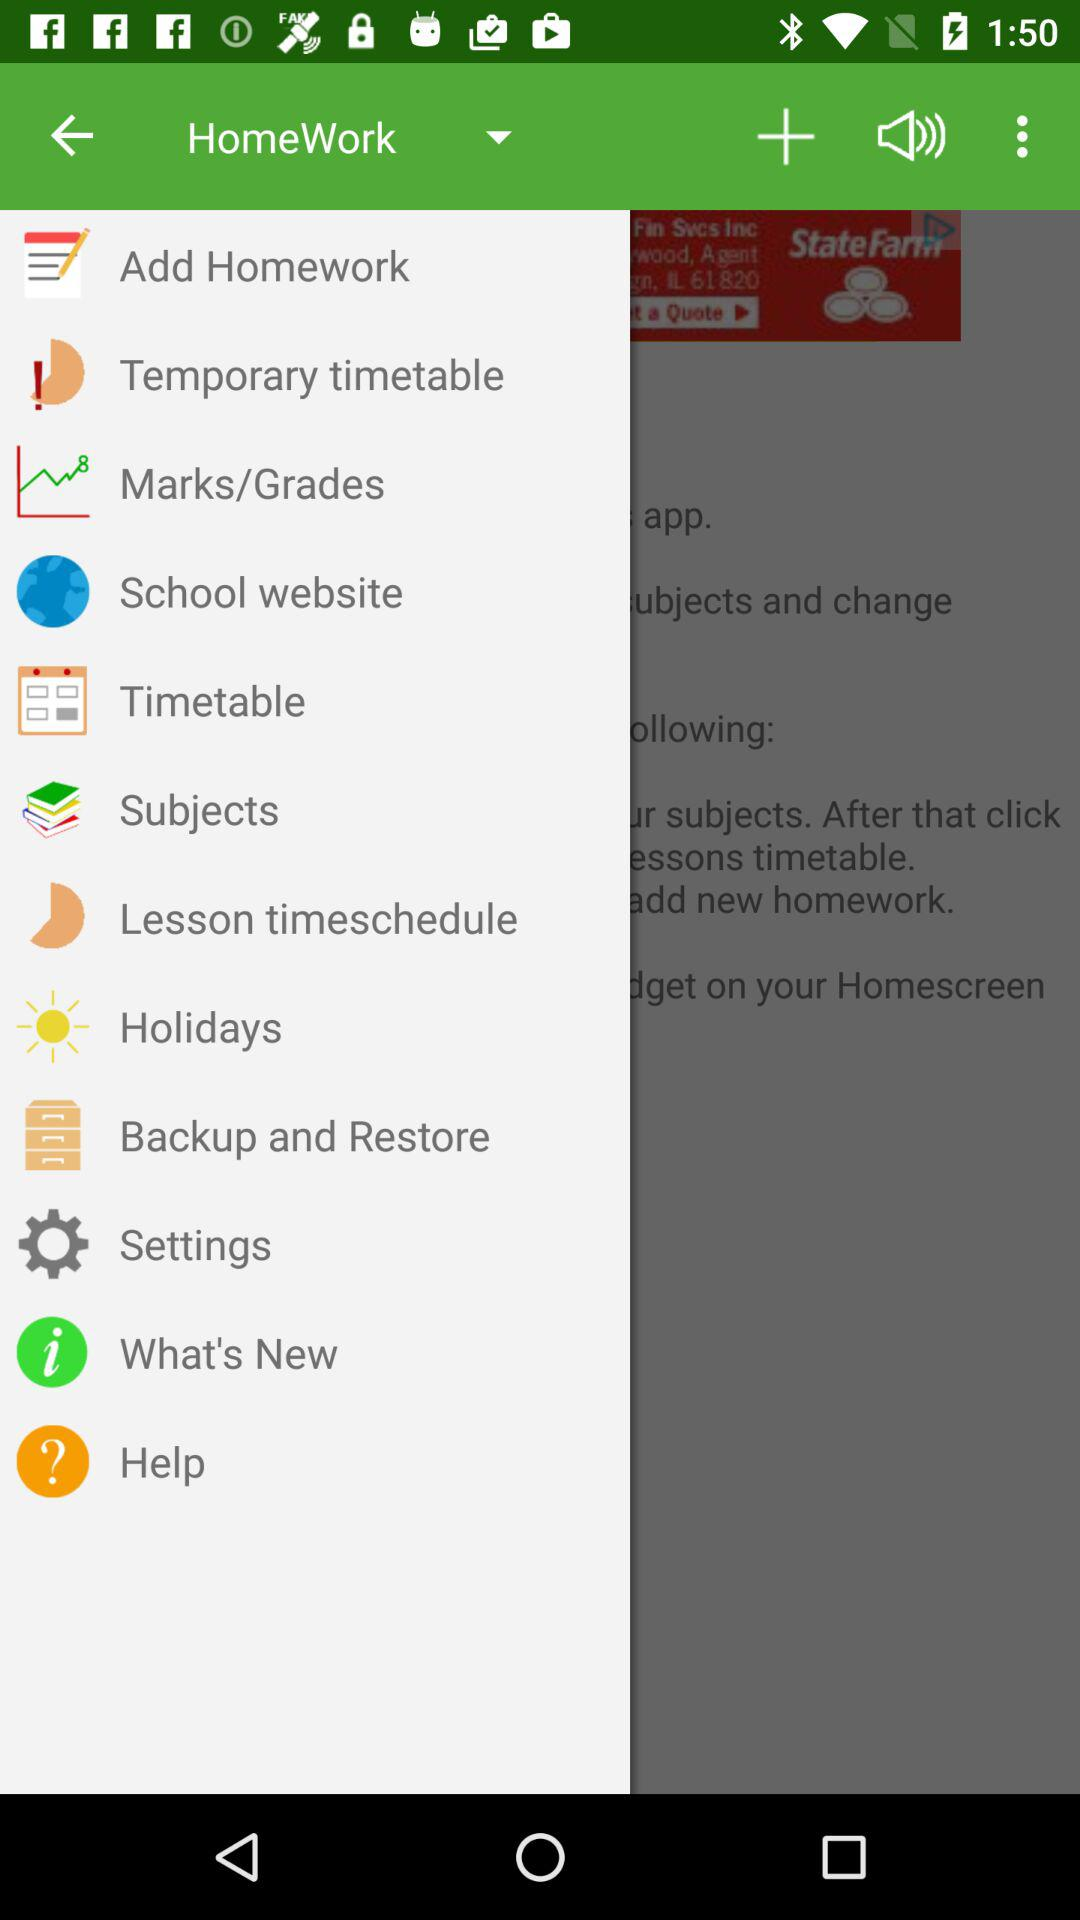Which option is selected in the dropdown? The selected option is "HomeWork". 